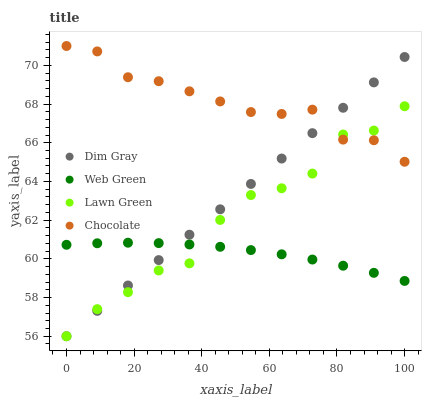Does Web Green have the minimum area under the curve?
Answer yes or no. Yes. Does Chocolate have the maximum area under the curve?
Answer yes or no. Yes. Does Dim Gray have the minimum area under the curve?
Answer yes or no. No. Does Dim Gray have the maximum area under the curve?
Answer yes or no. No. Is Dim Gray the smoothest?
Answer yes or no. Yes. Is Lawn Green the roughest?
Answer yes or no. Yes. Is Web Green the smoothest?
Answer yes or no. No. Is Web Green the roughest?
Answer yes or no. No. Does Lawn Green have the lowest value?
Answer yes or no. Yes. Does Web Green have the lowest value?
Answer yes or no. No. Does Chocolate have the highest value?
Answer yes or no. Yes. Does Dim Gray have the highest value?
Answer yes or no. No. Is Web Green less than Chocolate?
Answer yes or no. Yes. Is Chocolate greater than Web Green?
Answer yes or no. Yes. Does Chocolate intersect Lawn Green?
Answer yes or no. Yes. Is Chocolate less than Lawn Green?
Answer yes or no. No. Is Chocolate greater than Lawn Green?
Answer yes or no. No. Does Web Green intersect Chocolate?
Answer yes or no. No. 